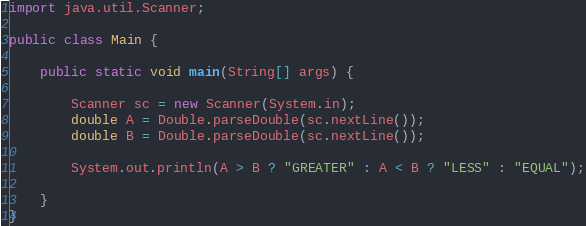Convert code to text. <code><loc_0><loc_0><loc_500><loc_500><_Java_>import java.util.Scanner;

public class Main {

    public static void main(String[] args) {

        Scanner sc = new Scanner(System.in);
        double A = Double.parseDouble(sc.nextLine());
        double B = Double.parseDouble(sc.nextLine());

        System.out.println(A > B ? "GREATER" : A < B ? "LESS" : "EQUAL");

    }
}
</code> 